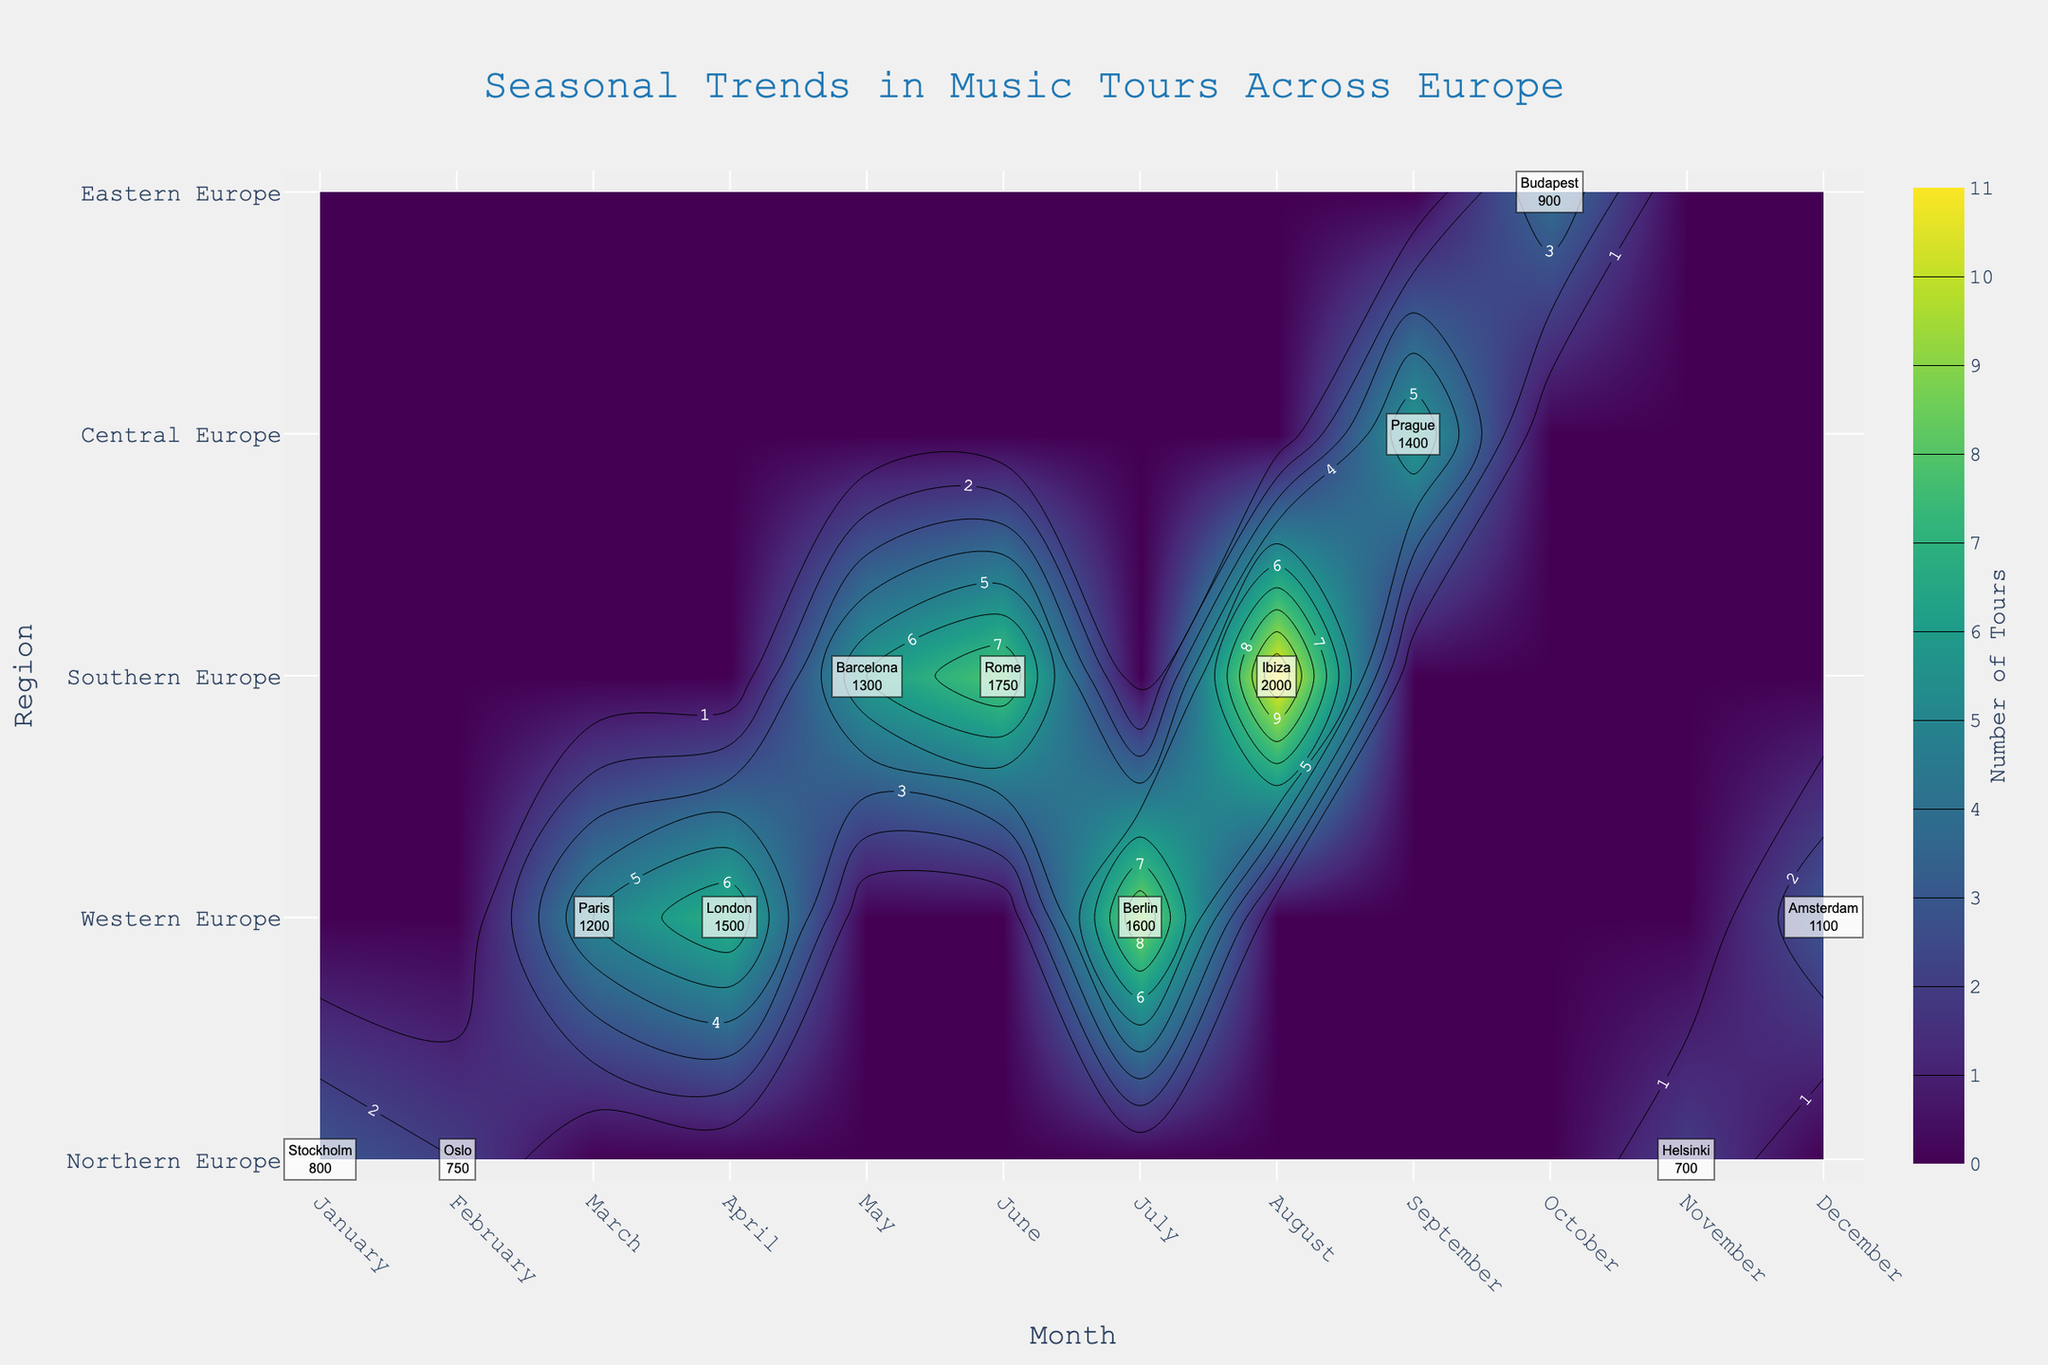What is the title of the figure? The title is located at the top of the figure, directly indicating the main subject. It reads, "Seasonal Trends in Music Tours Across Europe".
Answer: Seasonal Trends in Music Tours Across Europe Which month and region have the highest number of tours? Look at the contour plot and find the highest value represented by the color intensity or the contours' labels. The highest value appears in August within Southern Europe.
Answer: August, Southern Europe How many tours took place in Northern Europe in January? Identify Northern Europe in the y-axis and locate January on the x-axis. Check the contour label or annotation which shows the number 3.
Answer: 3 What is the average audience size for tours in April in Western Europe? Locate April on the x-axis and Western Europe on the y-axis. The annotation for London shows an average audience size of 1500.
Answer: 1500 Which city in Southern Europe had the highest average audience in June? Check June on the x-axis and Southern Europe on the y-axis. Compare annotations for cities in Southern Europe; Rome is listed with an average audience of 1750.
Answer: Rome Compare the number of tours in Western Europe in March and July. Which month had more tours? Locate Western Europe on the y-axis and compare the number of tours in March and July. March has 5 tours (Paris) and July has 9 tours (Berlin).
Answer: July What is the trend for the number of tours in Western Europe from March to August? Follow the Western Europe row from March to August. The numbers increase from 5 (March) to 7 (April), maintain at 7 (May), increase to 8 (June), and then to 9 (July), and peak at 11 in August.
Answer: Increasing trend Which city in Eastern Europe had tours in October, and what was the average audience size? Locate October on the x-axis and Eastern Europe on the y-axis. The annotation shows Budapest with an average audience of 900.
Answer: Budapest, 900 How many tours took place in Central Europe in September and what was the average audience size? Locate Central Europe on the y-axis and check September on the x-axis. The annotation shows that Prague had 6 tours with an average audience of 1400.
Answer: 6 tours, 1400 Calculate the total number of tours in Northern Europe across all months. Summarize the values for Northern Europe for all months. January (3), February (2), November (2), which sums up to 3 + 2 + 2 = 7.
Answer: 7 tours 